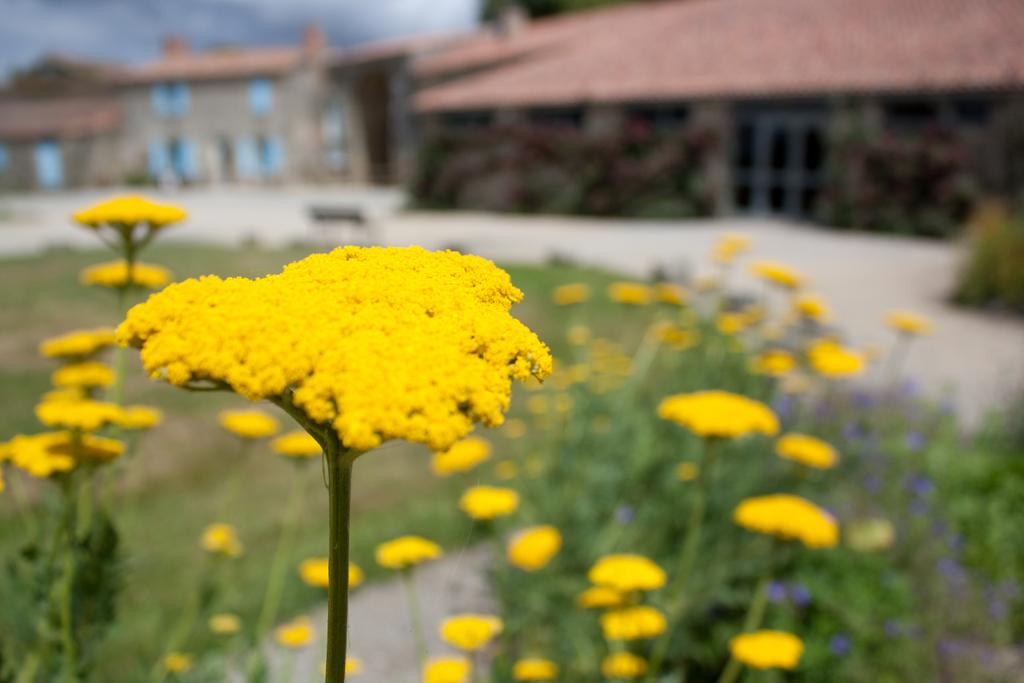What type of flowers can be seen in the image? There are yellow color flowers in the image. Where are the flowers located? The flowers are on plants. What can be seen in the background of the image? There are houses and the sky visible in the background of the image. What color is the tail of the dog in the image? There is no dog present in the image, so there is no tail to describe. 